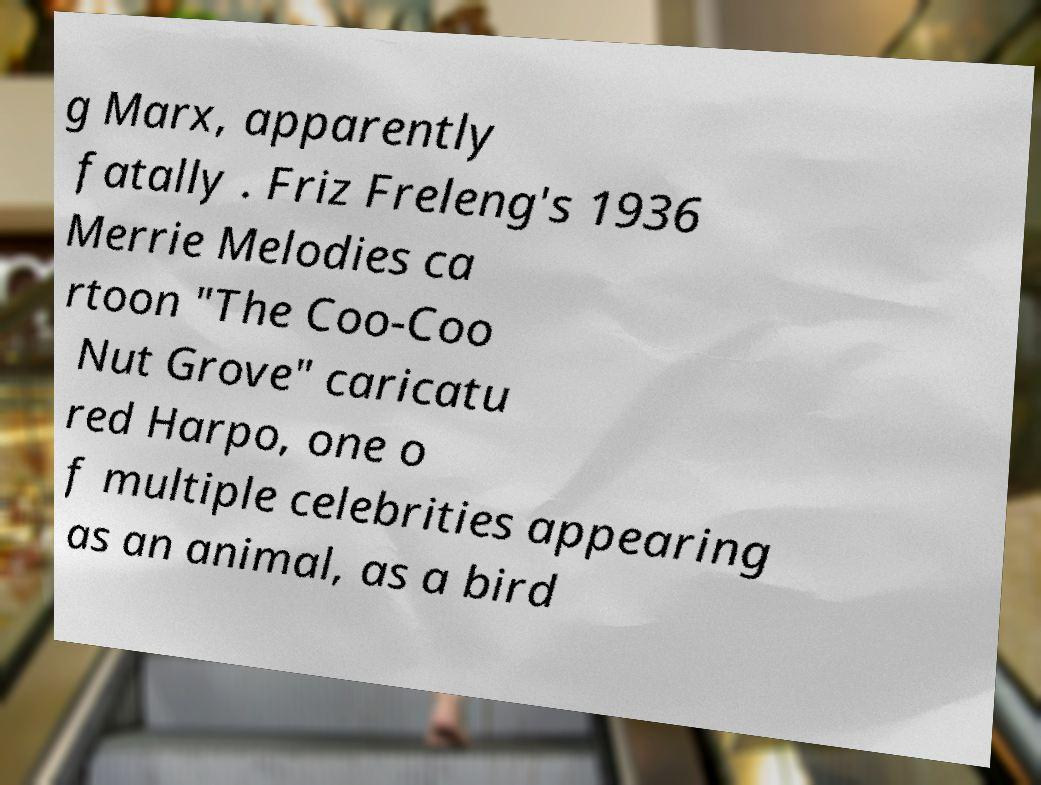There's text embedded in this image that I need extracted. Can you transcribe it verbatim? g Marx, apparently fatally . Friz Freleng's 1936 Merrie Melodies ca rtoon "The Coo-Coo Nut Grove" caricatu red Harpo, one o f multiple celebrities appearing as an animal, as a bird 